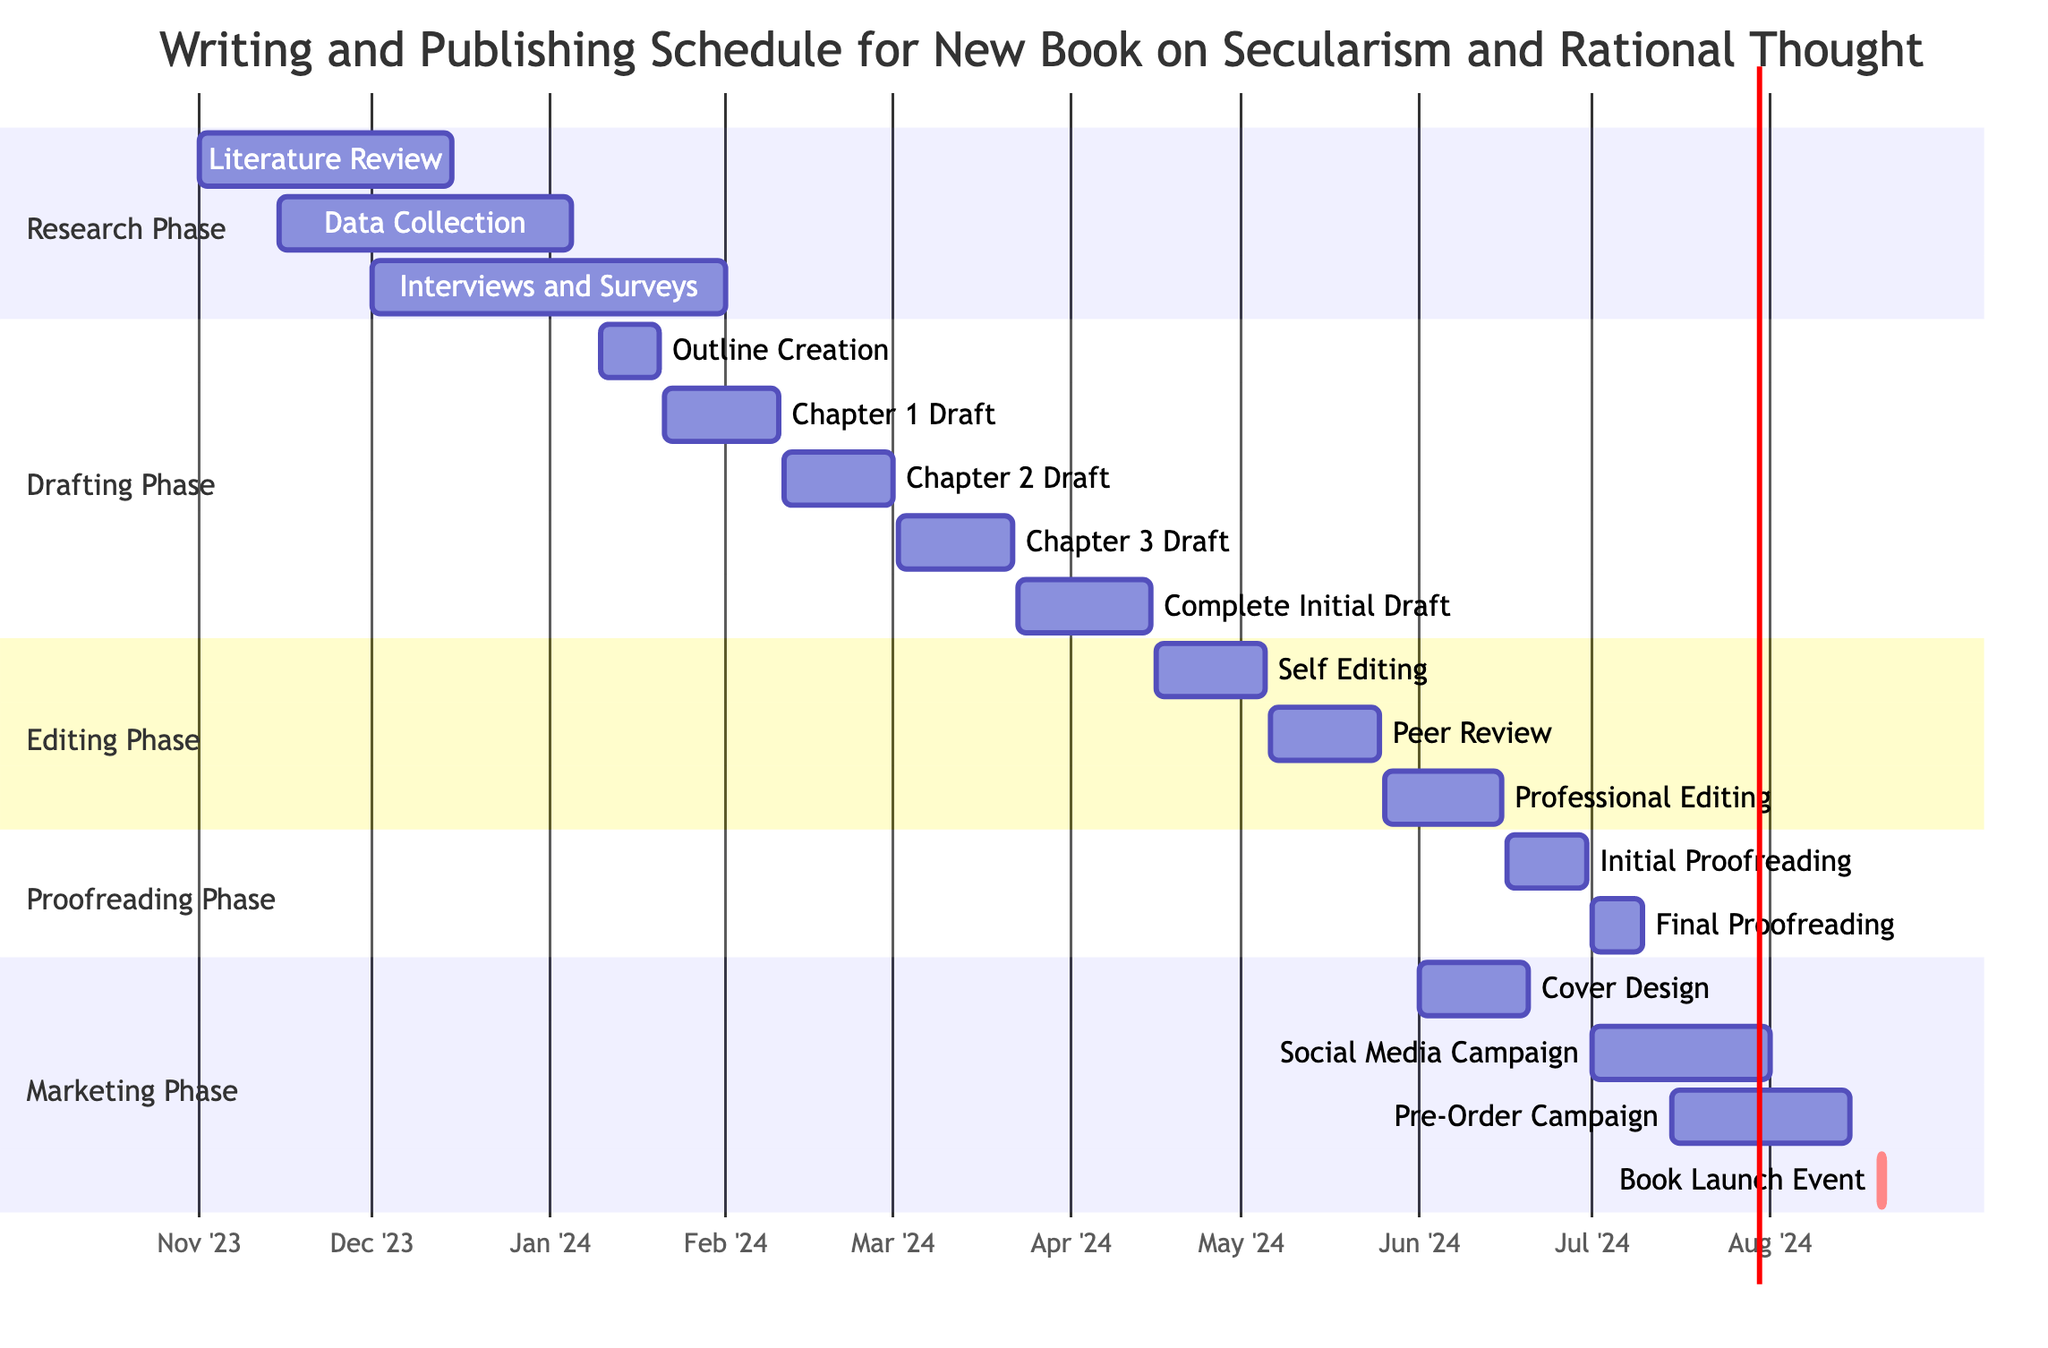What is the duration of the Literature Review phase? The Literature Review phase starts on November 1, 2023, and ends on December 15, 2023. To find the duration, I subtract the start date from the end date, giving me 45 days.
Answer: 45 days When does the Social Media Campaign start? In the Marketing Phase, the Social Media Campaign starts on July 1, 2024. This information is directly listed in the diagram under that specific section.
Answer: July 1, 2024 How many days does the Editing Phase last? The Editing Phase includes three sub-phases: Self Editing, Peer Review, and Professional Editing. I calculate the duration of each (20 days + 20 days + 21 days) to find the total duration is 61 days.
Answer: 61 days Which phase does the Book Launch Event belong to? The Book Launch Event is listed under the Marketing Phase, which directly indicates the section it belongs to.
Answer: Marketing Phase What activity is scheduled immediately after the Complete Initial Draft? The next activity after the Complete Initial Draft is Self Editing, which starts on April 16, 2024, immediately after the drafting phase concludes.
Answer: Self Editing What is the end date of the Initial Proofreading? The Initial Proofreading phase ends on June 30, 2024, as shown in the diagram. This indicates the final day of that specific activity.
Answer: June 30, 2024 What is the overlap between the Data Collection and Interviews and Surveys phases? Data Collection starts on November 15, 2023, and ends on January 5, 2024. Interviews and Surveys start on December 1, 2023, and finish on February 1, 2024. I find the overlap between these dates, which is from December 1, 2023, to January 5, 2024, creating a 36-day overlap.
Answer: 36 days How long does the Pre-Order Campaign last? The Pre-Order Campaign starts on July 15, 2024, and ends on August 15, 2024. By subtracting the start date from the end date, I find that it lasts for 31 days.
Answer: 31 days Which activity is critical in the Marketing Phase? In the Marketing Phase, the Book Launch Event is marked as critical ('crit'), indicating its importance in the overall schedule.
Answer: Book Launch Event 